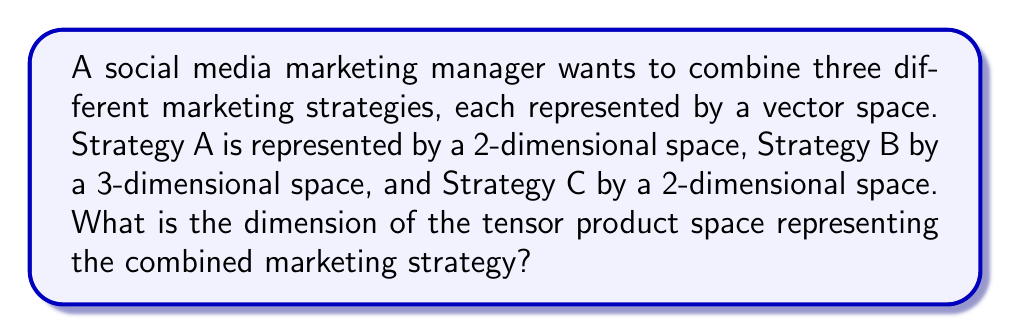Solve this math problem. Let's approach this step-by-step:

1) In representation theory, combining strategies can be modeled using tensor products of vector spaces.

2) Given:
   - Strategy A: $V_A$ (2-dimensional)
   - Strategy B: $V_B$ (3-dimensional)
   - Strategy C: $V_C$ (2-dimensional)

3) We need to compute the tensor product: $V_A \otimes V_B \otimes V_C$

4) A key property of tensor products is that the dimension of the resulting space is the product of the dimensions of the individual spaces:

   $\dim(V_A \otimes V_B \otimes V_C) = \dim(V_A) \cdot \dim(V_B) \cdot \dim(V_C)$

5) Substituting the given dimensions:

   $\dim(V_A \otimes V_B \otimes V_C) = 2 \cdot 3 \cdot 2$

6) Calculate:
   $2 \cdot 3 \cdot 2 = 12$

Therefore, the dimension of the tensor product space representing the combined marketing strategy is 12.
Answer: 12 